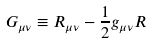<formula> <loc_0><loc_0><loc_500><loc_500>G _ { \mu \nu } \equiv R _ { \mu \nu } - \frac { 1 } { 2 } g _ { \mu \nu } R</formula> 